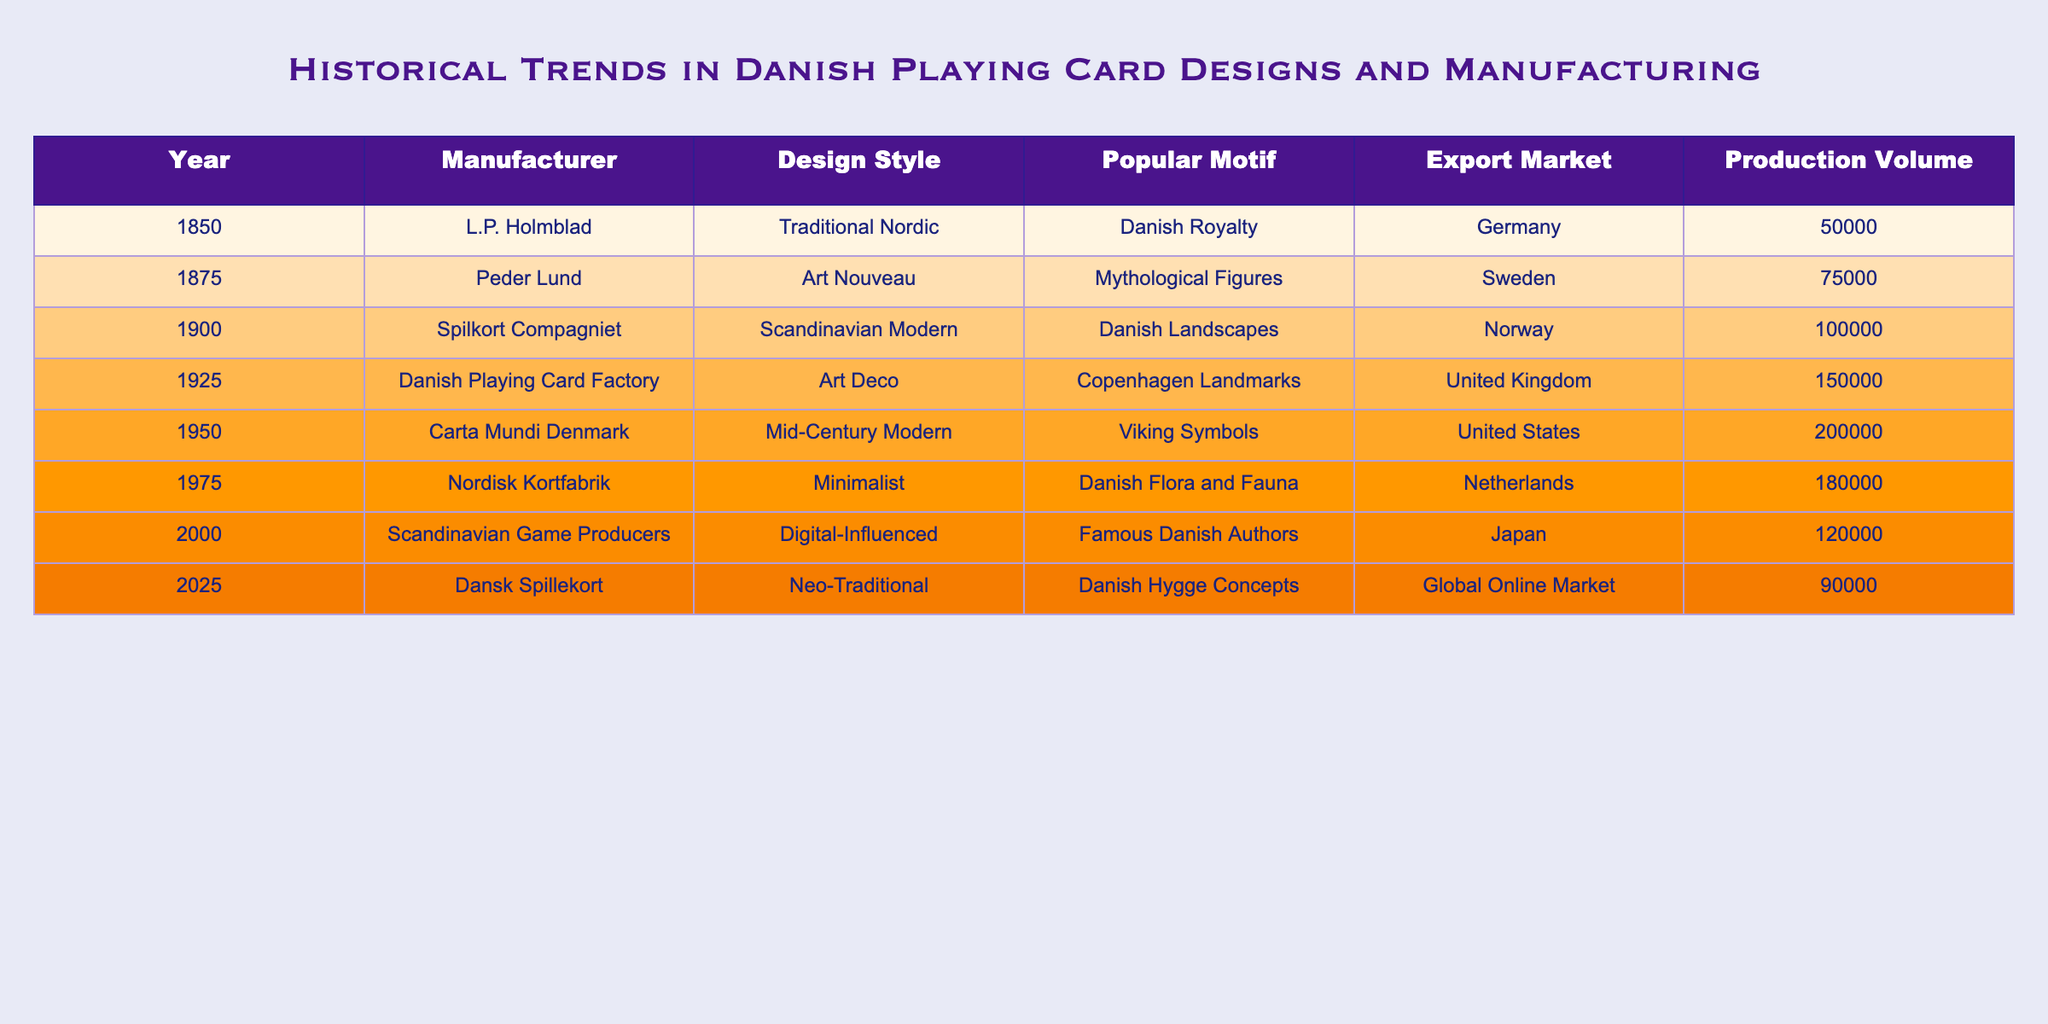What year did Carta Mundi Denmark manufacture cards? Referring to the table, we can see that Carta Mundi Denmark produced cards in the year 1950.
Answer: 1950 Which manufacturer had the highest production volume? By examining the production volume column, we find that the Danish Playing Card Factory had the highest production volume of 150,000 cards in 1925.
Answer: Danish Playing Card Factory What was the popular motif for the cards made by Peder Lund? Looking at the table, Peder Lund's cards featured Mythological Figures as the popular motif in 1875.
Answer: Mythological Figures What is the total production volume of cards from the years 1850 to 2000? To find the total, we add the production volumes for those years: 50,000 + 75,000 + 100,000 + 150,000 + 200,000 + 180,000 + 120,000 = 975,000.
Answer: 975,000 Is it true that Scandinavian Game Producers exported to Japan? The table indicates that Scandinavian Game Producers did export to Japan, confirming this statement is true.
Answer: Yes Which design style was used by the manufacturer Nordisk Kortfabrik? According to the table, Nordisk Kortfabrik utilized a Minimalist design style in 1975.
Answer: Minimalist What was the average production volume for cards manufactured between 1925 and 2025? The production volumes for those years are 150,000 (1925), 200,000 (1950), 180,000 (1975), 120,000 (2000), and 90,000 (2025). The total is 150,000 + 200,000 + 180,000 + 120,000 + 90,000 = 840,000. Dividing by 5 gives an average of 168,000.
Answer: 168,000 Which popular motif was used for the cards in the year 2000? Checking the data, the popular motif for cards produced in 2000 by Scandinavian Game Producers was Famous Danish Authors.
Answer: Famous Danish Authors Has the export market for cards consistently included Germany from 1850 to 2025? The table shows that Germany was the export market in 1850, but from 1875 onwards, different markets were targeted. Therefore, this statement is false.
Answer: No Which manufacturer had the least production volume in the 19th century? In the 19th century, the only manufacturer to produce cards was L.P. Holmblad in 1850, who had a production volume of 50,000.
Answer: L.P. Holmblad 